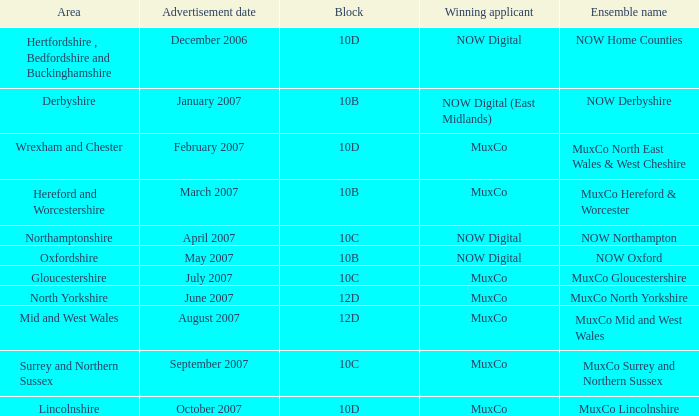Can you parse all the data within this table? {'header': ['Area', 'Advertisement date', 'Block', 'Winning applicant', 'Ensemble name'], 'rows': [['Hertfordshire , Bedfordshire and Buckinghamshire', 'December 2006', '10D', 'NOW Digital', 'NOW Home Counties'], ['Derbyshire', 'January 2007', '10B', 'NOW Digital (East Midlands)', 'NOW Derbyshire'], ['Wrexham and Chester', 'February 2007', '10D', 'MuxCo', 'MuxCo North East Wales & West Cheshire'], ['Hereford and Worcestershire', 'March 2007', '10B', 'MuxCo', 'MuxCo Hereford & Worcester'], ['Northamptonshire', 'April 2007', '10C', 'NOW Digital', 'NOW Northampton'], ['Oxfordshire', 'May 2007', '10B', 'NOW Digital', 'NOW Oxford'], ['Gloucestershire', 'July 2007', '10C', 'MuxCo', 'MuxCo Gloucestershire'], ['North Yorkshire', 'June 2007', '12D', 'MuxCo', 'MuxCo North Yorkshire'], ['Mid and West Wales', 'August 2007', '12D', 'MuxCo', 'MuxCo Mid and West Wales'], ['Surrey and Northern Sussex', 'September 2007', '10C', 'MuxCo', 'MuxCo Surrey and Northern Sussex'], ['Lincolnshire', 'October 2007', '10D', 'MuxCo', 'MuxCo Lincolnshire']]} Who is the victorious candidate of ensemble name muxco lincolnshire in block 10d? MuxCo. 